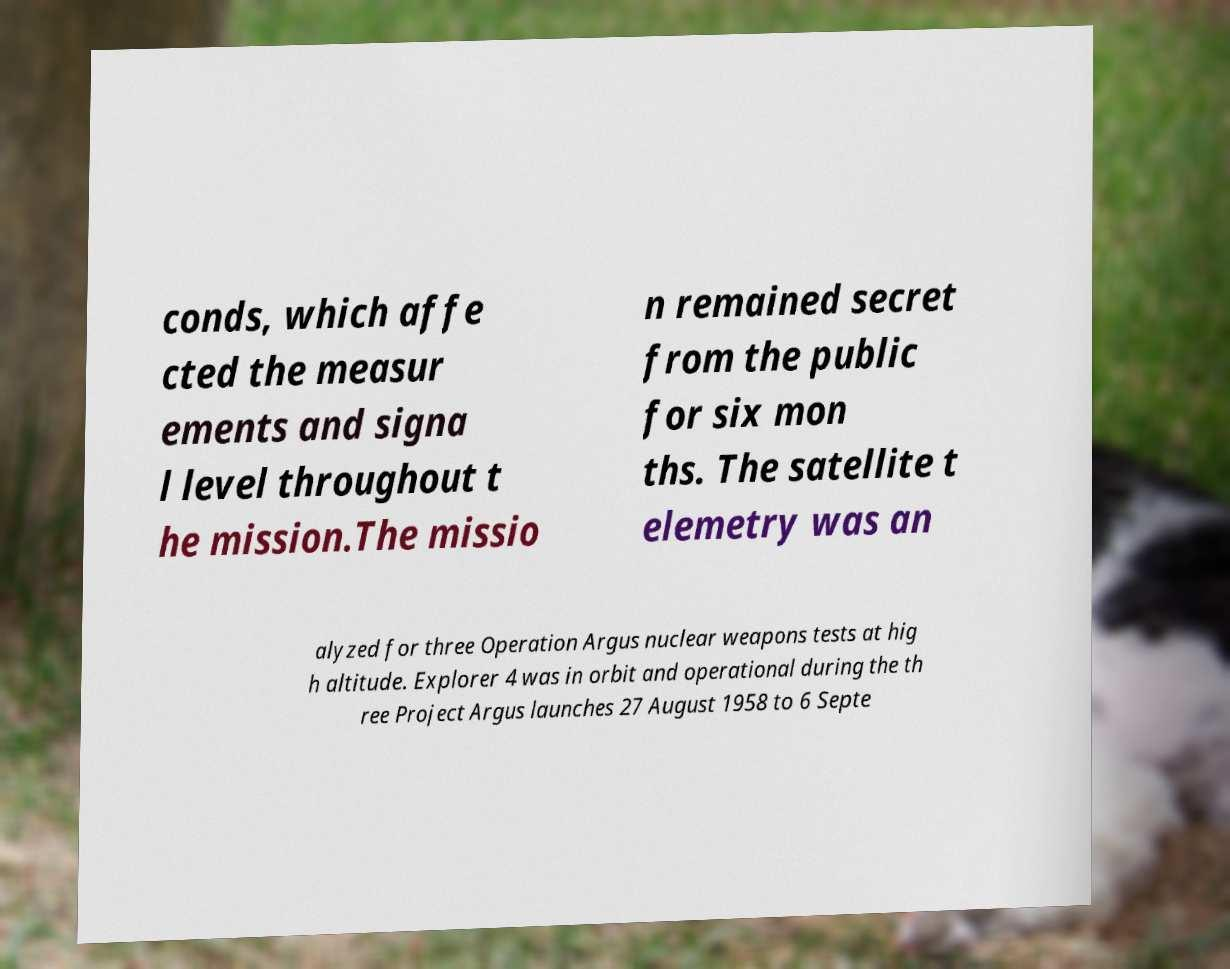Can you read and provide the text displayed in the image?This photo seems to have some interesting text. Can you extract and type it out for me? conds, which affe cted the measur ements and signa l level throughout t he mission.The missio n remained secret from the public for six mon ths. The satellite t elemetry was an alyzed for three Operation Argus nuclear weapons tests at hig h altitude. Explorer 4 was in orbit and operational during the th ree Project Argus launches 27 August 1958 to 6 Septe 